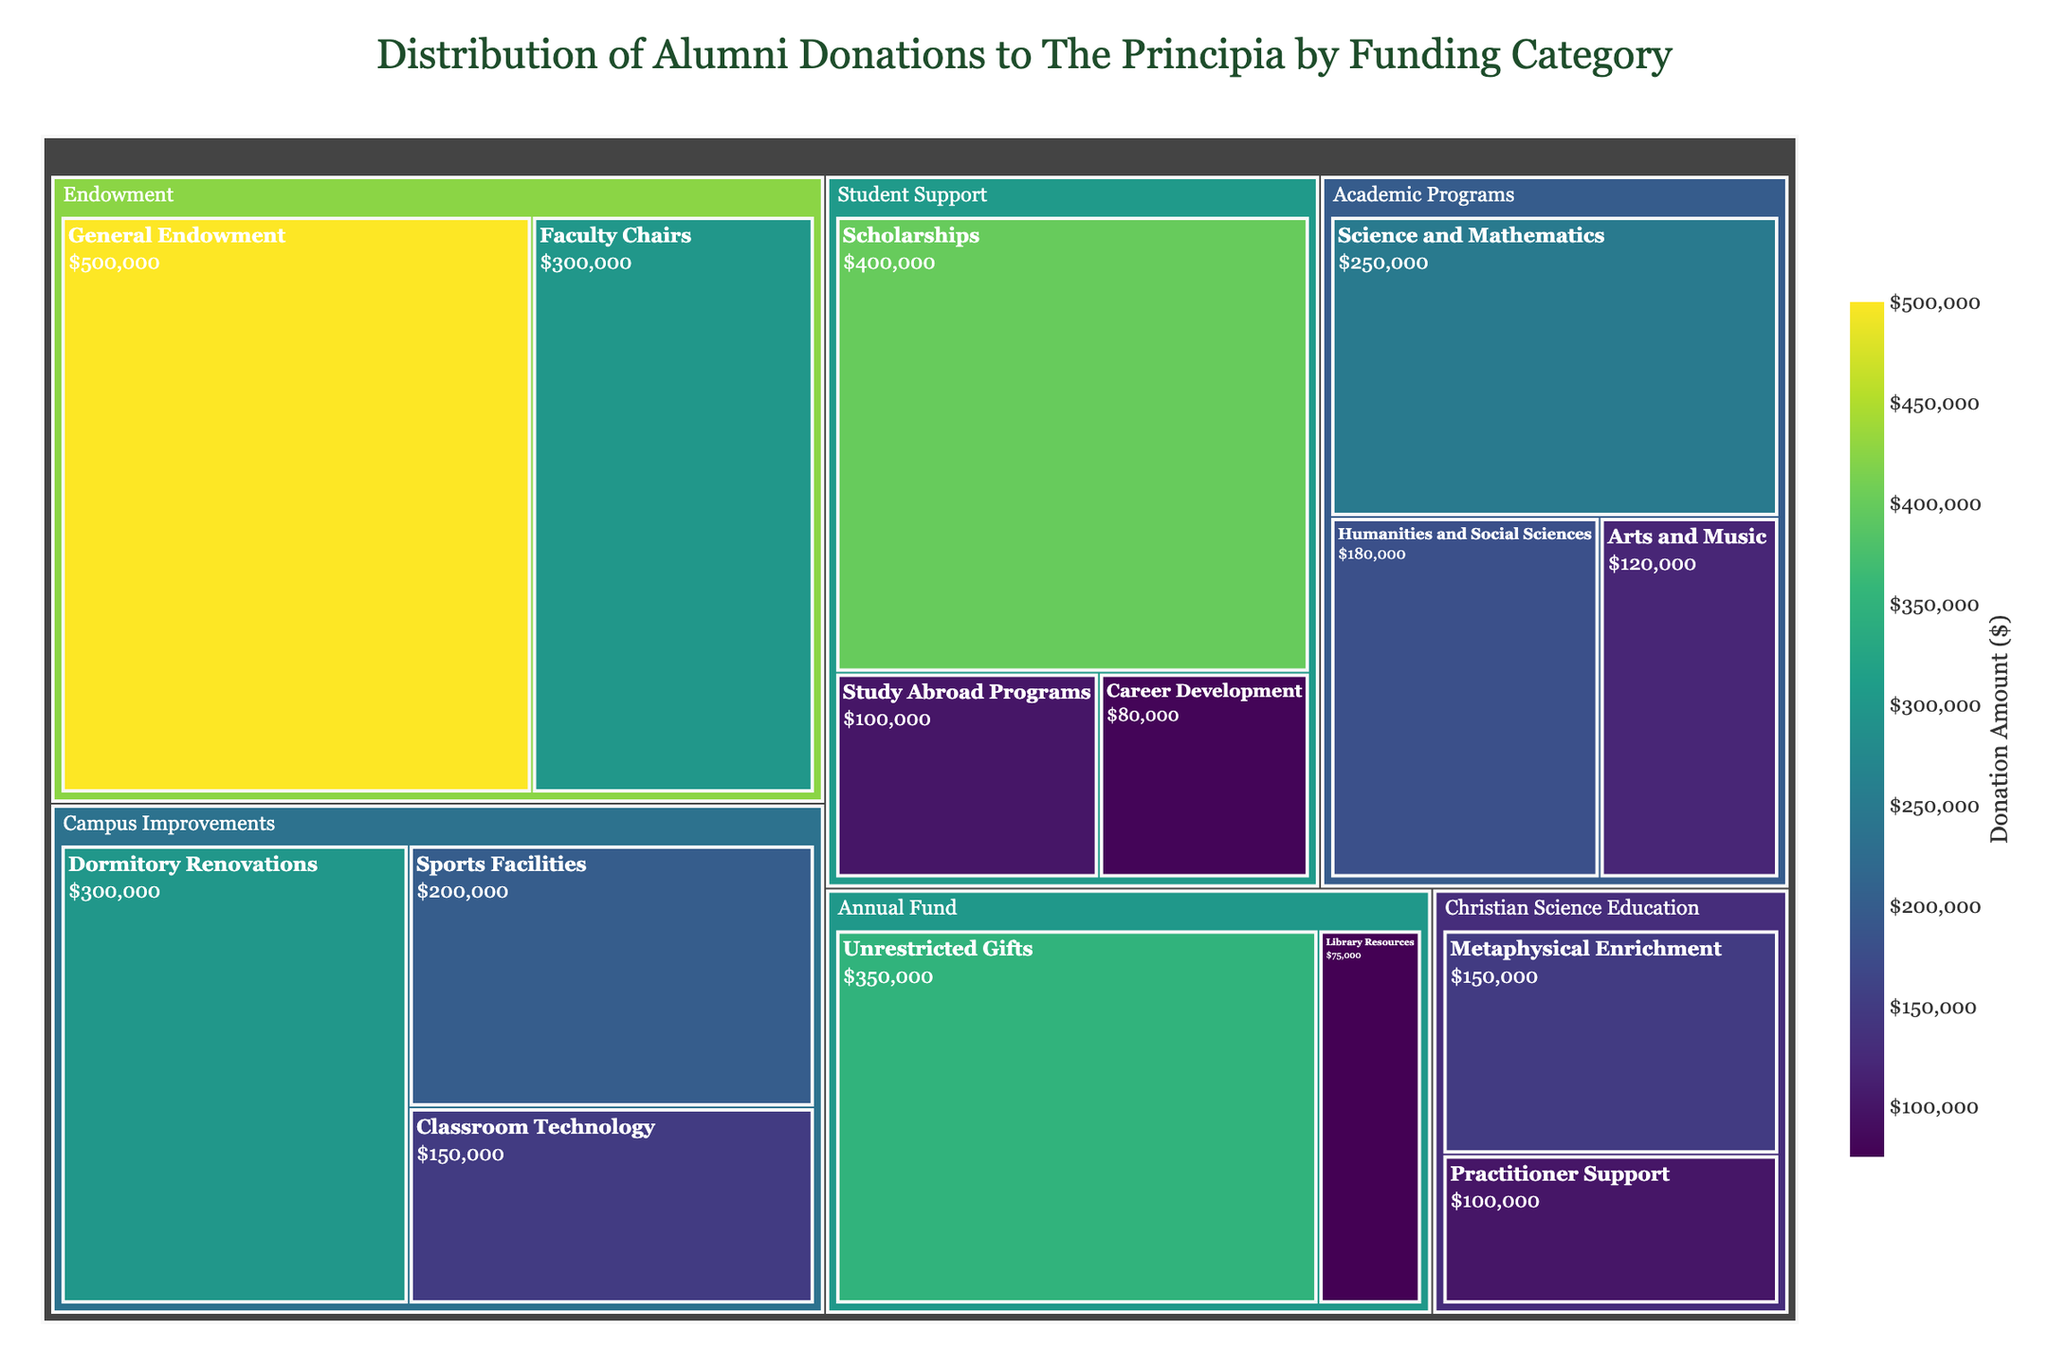What is the title of the treemap? The title of the treemap is usually located at the top of the figure. It summarizes the main topic or focus of the visual representation.
Answer: Distribution of Alumni Donations to The Principia by Funding Category Which category received the highest total donations? Look at the size and color of the blocks in the treemap. The largest and darkest block indicates the category with the highest total donations.
Answer: Endowment What subcategory received the highest donations within Student Support? Identify the area labeled as Student Support on the treemap, then observe the subcategories within it to see which has the largest block or the highest value.
Answer: Scholarships How much money was donated to Classroom Technology? Find the Classroom Technology subcategory in the treemap and read the value associated with it.
Answer: $150,000 Which category has the least variety of subcategories? Count the number of subcategories within each primary category and determine which has the fewest.
Answer: Annual Fund How much more was donated to Dormitory Renovations compared to Career Development? Locate the values for both Dormitory Renovations and Career Development, then subtract the latter from the former. Dormitory Renovations received $300,000 and Career Development received $80,000.
Answer: $220,000 What is the total donation amount for Academic Programs? Sum the values of all subcategories under Academic Programs: Science and Mathematics ($250,000), Humanities and Social Sciences ($180,000), and Arts and Music ($120,000). The sum is $250,000 + $180,000 + $120,000.
Answer: $550,000 Which funding category received more donations: Campus Improvements or Christian Science Education? Sum the donation values for the subcategories under each category. Campus Improvements: Dormitory Renovations ($300,000), Classroom Technology ($150,000), and Sports Facilities ($200,000) sum to $650,000. Christian Science Education: Metaphysical Enrichment ($150,000) and Practitioner Support ($100,000) sum to $250,000. Compare the sums.
Answer: Campus Improvements What is the total amount of unrestricted gifts donated? Unrestricted gifts are under the Annual Fund category, represented as a single subcategory with the value given directly in the treemap.
Answer: $350,000 Which subcategory within Academic Programs has the smallest donation amount? Identify the subcategories within Academic Programs and compare their values: Science and Mathematics ($250,000), Humanities and Social Sciences ($180,000), and Arts and Music ($120,000). The smallest among these is Arts and Music.
Answer: Arts and Music 